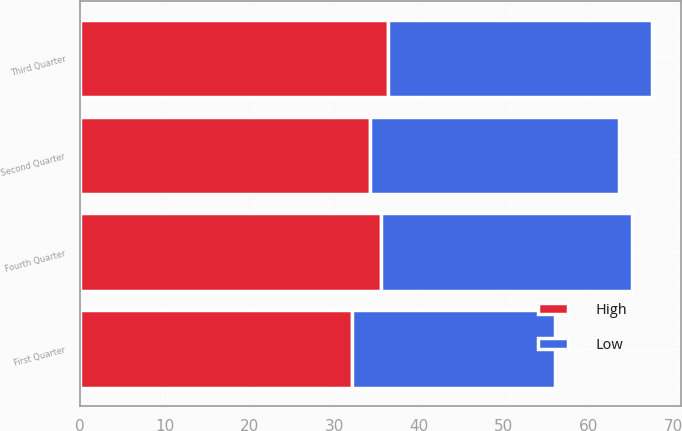Convert chart. <chart><loc_0><loc_0><loc_500><loc_500><stacked_bar_chart><ecel><fcel>Fourth Quarter<fcel>Third Quarter<fcel>Second Quarter<fcel>First Quarter<nl><fcel>High<fcel>35.58<fcel>36.35<fcel>34.26<fcel>32.12<nl><fcel>Low<fcel>29.57<fcel>31.18<fcel>29.37<fcel>23.95<nl></chart> 